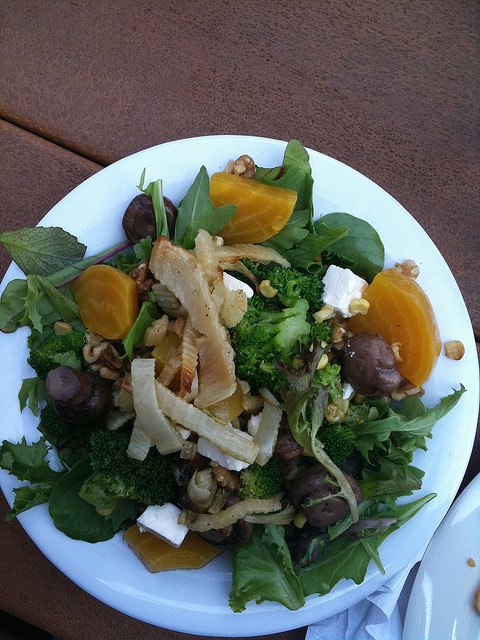Describe the objects in this image and their specific colors. I can see broccoli in black, darkgreen, and gray tones, broccoli in black, darkgreen, and green tones, broccoli in black and darkgreen tones, broccoli in black and darkgreen tones, and broccoli in black and darkgreen tones in this image. 